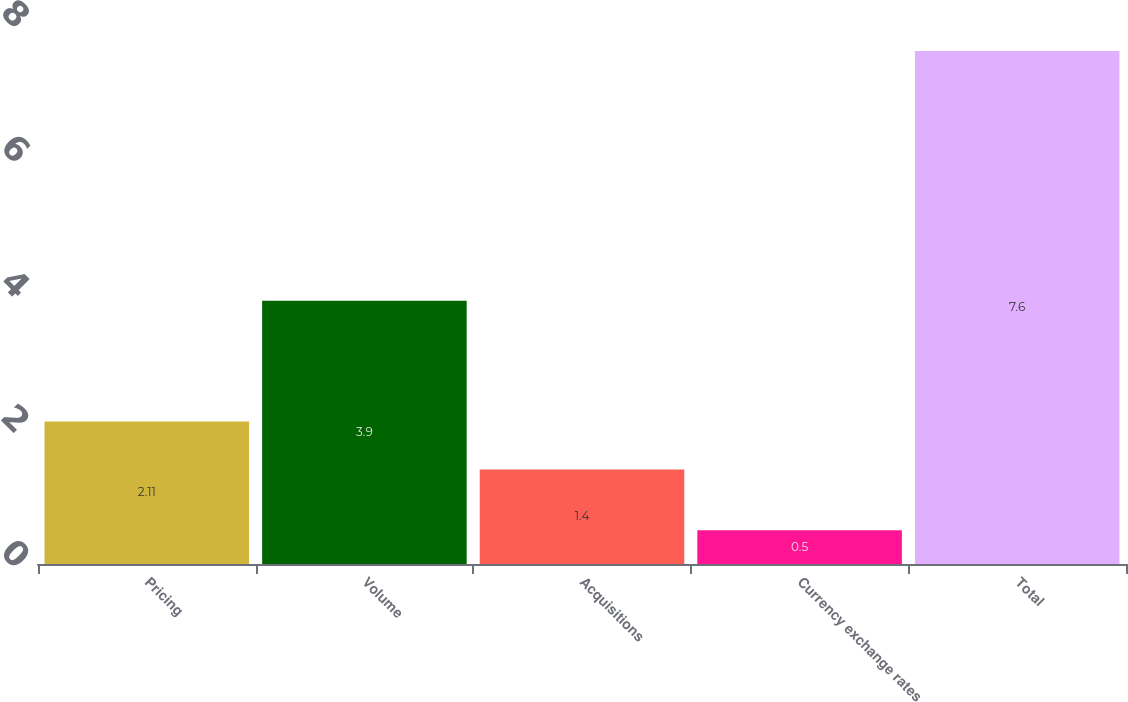Convert chart to OTSL. <chart><loc_0><loc_0><loc_500><loc_500><bar_chart><fcel>Pricing<fcel>Volume<fcel>Acquisitions<fcel>Currency exchange rates<fcel>Total<nl><fcel>2.11<fcel>3.9<fcel>1.4<fcel>0.5<fcel>7.6<nl></chart> 